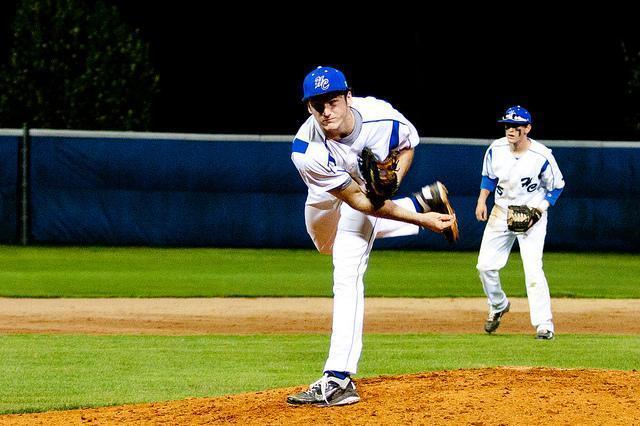How many people are there?
Give a very brief answer. 2. 